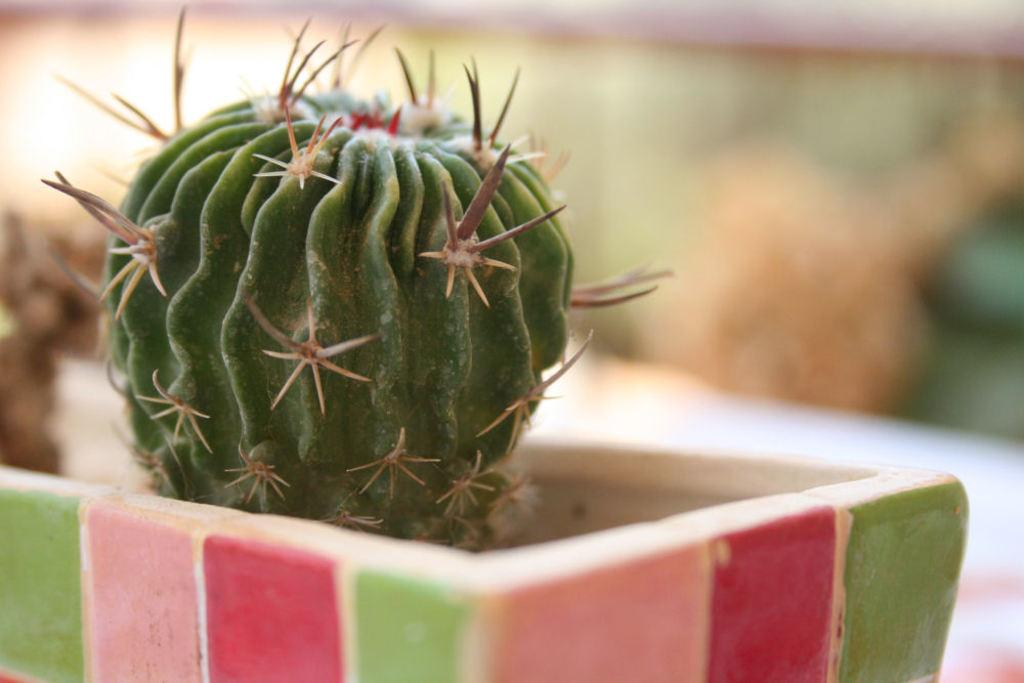What type of plant is in the image? There is a cactus plant in the image. Where is the cactus plant located? The cactus plant is in a flower pot. What is the cactus plant placed in? The cactus plant is in a flower pot. Can you see any steam coming from the cactus plant in the image? No, there is no steam present in the image. 